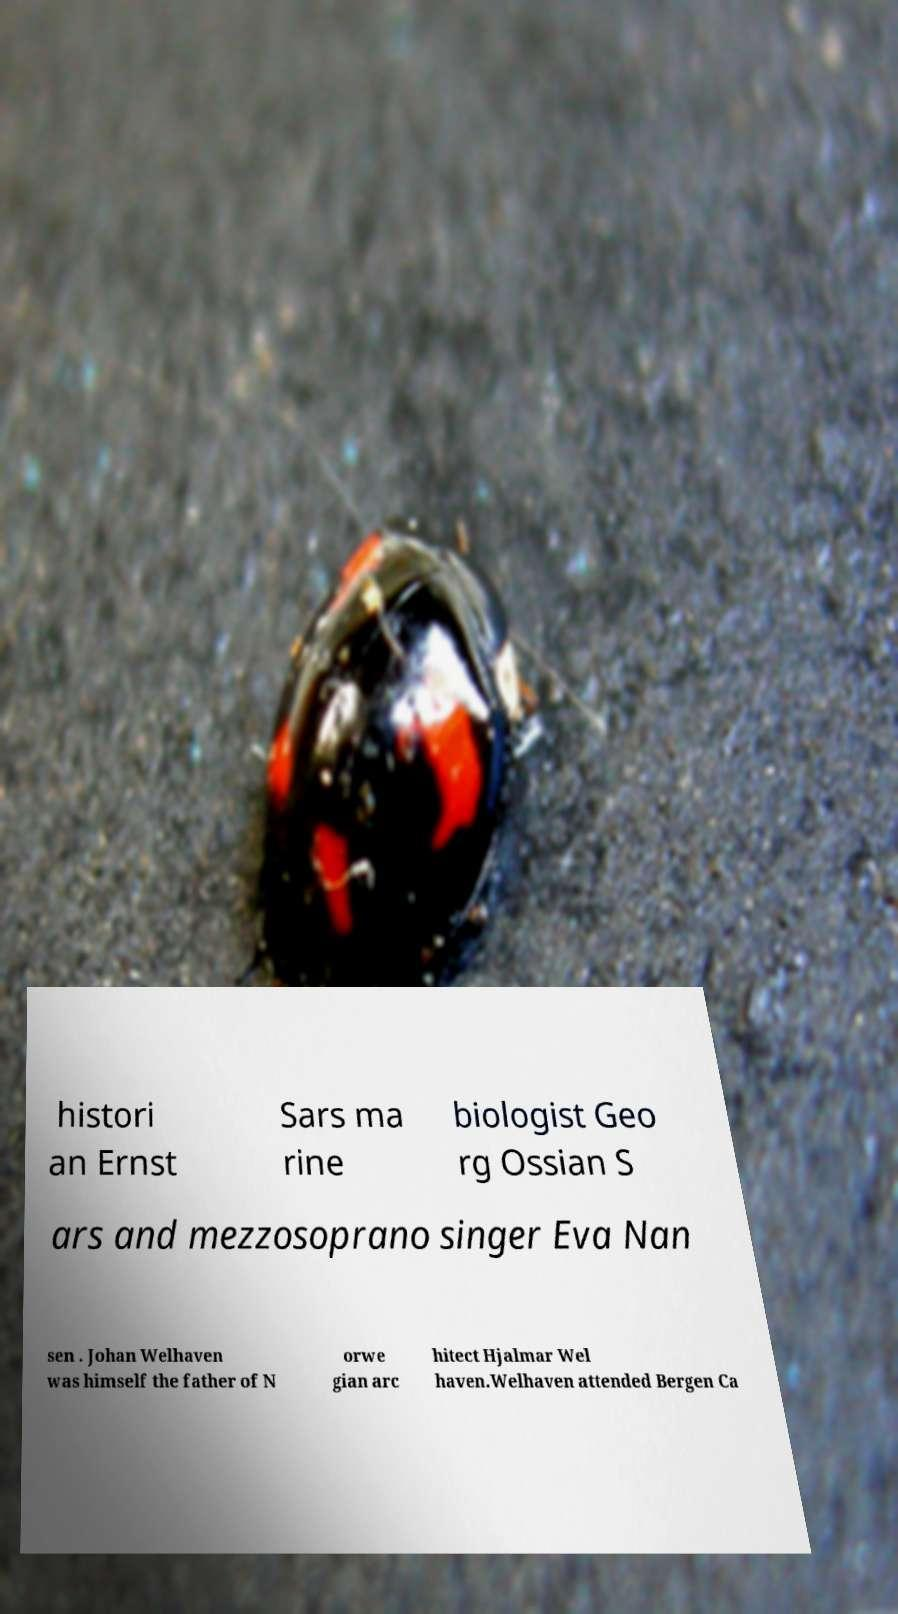There's text embedded in this image that I need extracted. Can you transcribe it verbatim? histori an Ernst Sars ma rine biologist Geo rg Ossian S ars and mezzosoprano singer Eva Nan sen . Johan Welhaven was himself the father of N orwe gian arc hitect Hjalmar Wel haven.Welhaven attended Bergen Ca 